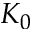<formula> <loc_0><loc_0><loc_500><loc_500>K _ { 0 }</formula> 